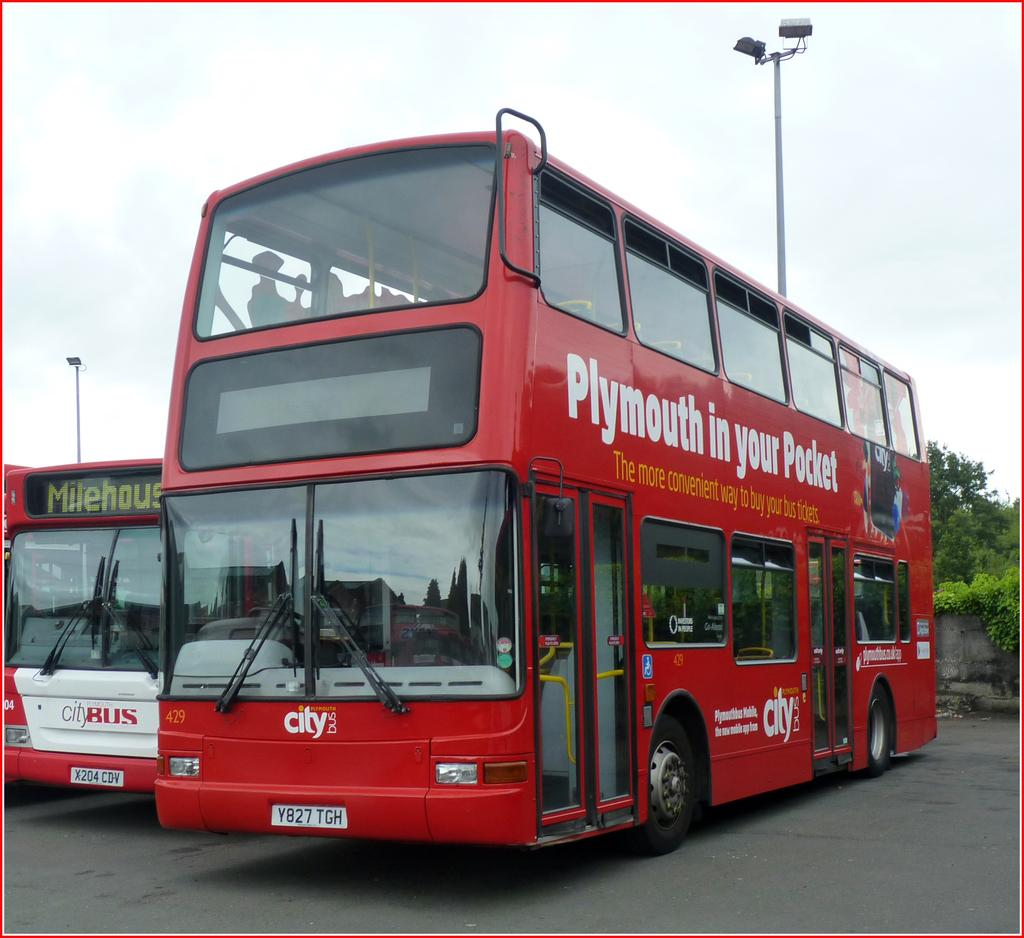Provide a one-sentence caption for the provided image. A city tour where you can access Plymouth in your Pocket. 